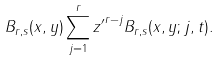<formula> <loc_0><loc_0><loc_500><loc_500>B _ { r , s } ( x , y ) \sum _ { j = 1 } ^ { r } { z ^ { \prime } } ^ { r - j } B _ { r , s } ( x , y ; j , t ) .</formula> 